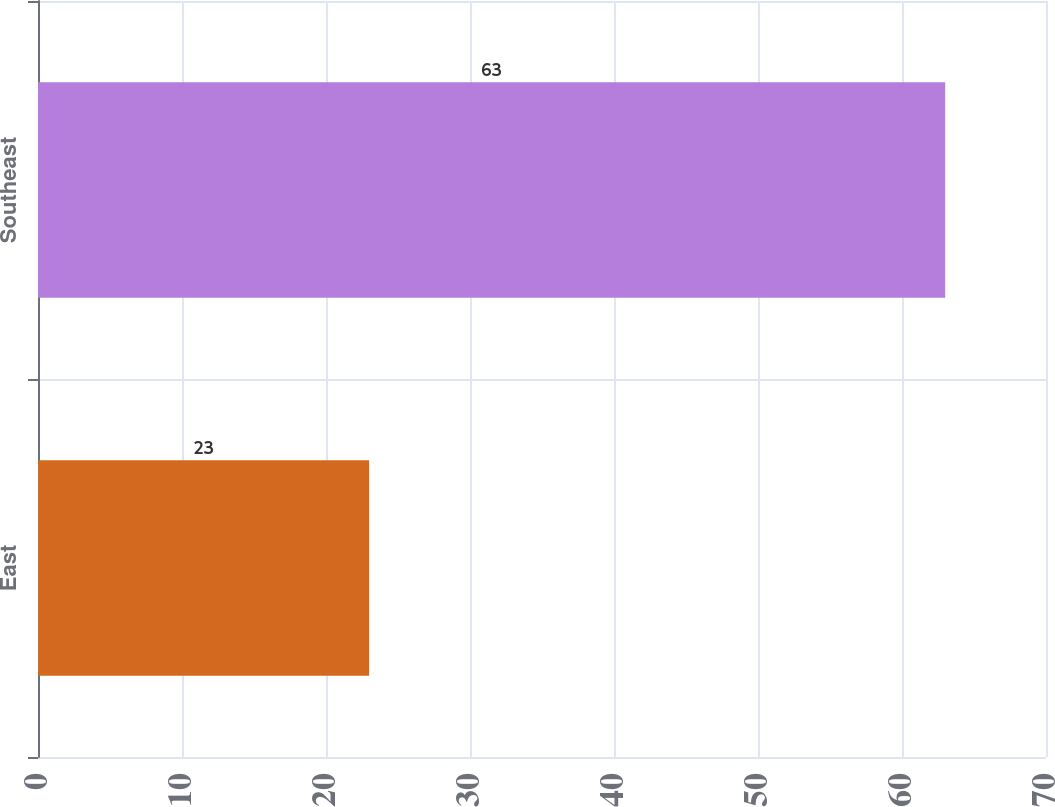<chart> <loc_0><loc_0><loc_500><loc_500><bar_chart><fcel>East<fcel>Southeast<nl><fcel>23<fcel>63<nl></chart> 